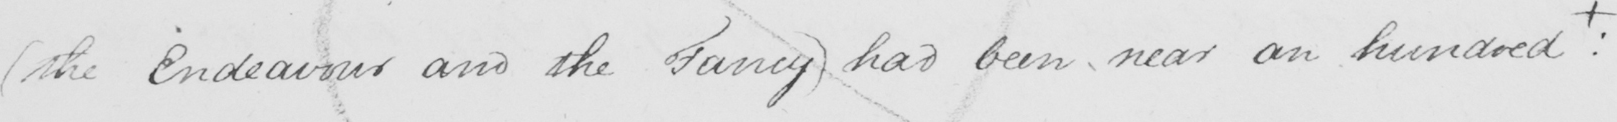Can you tell me what this handwritten text says? ( the Endeavour and the Fancy )  had been near an hundred  +  : 